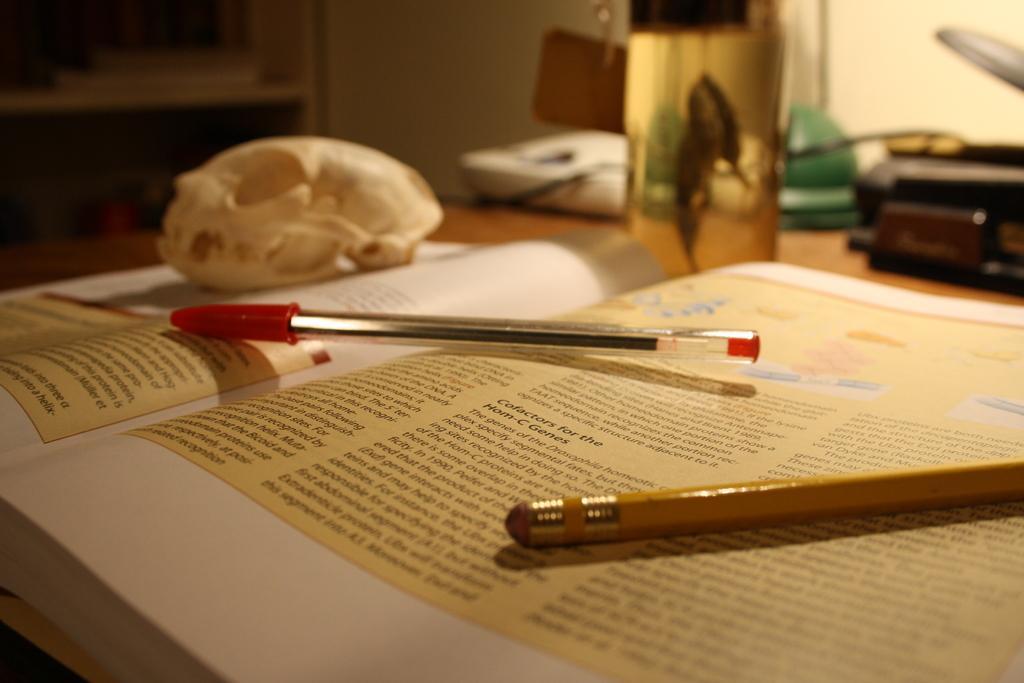How would you summarize this image in a sentence or two? In this image in the foreground there is one book, on the book there are two pens and some object. In the background there are phones, bottle, handbag, wall, cupboard and some other objects. 